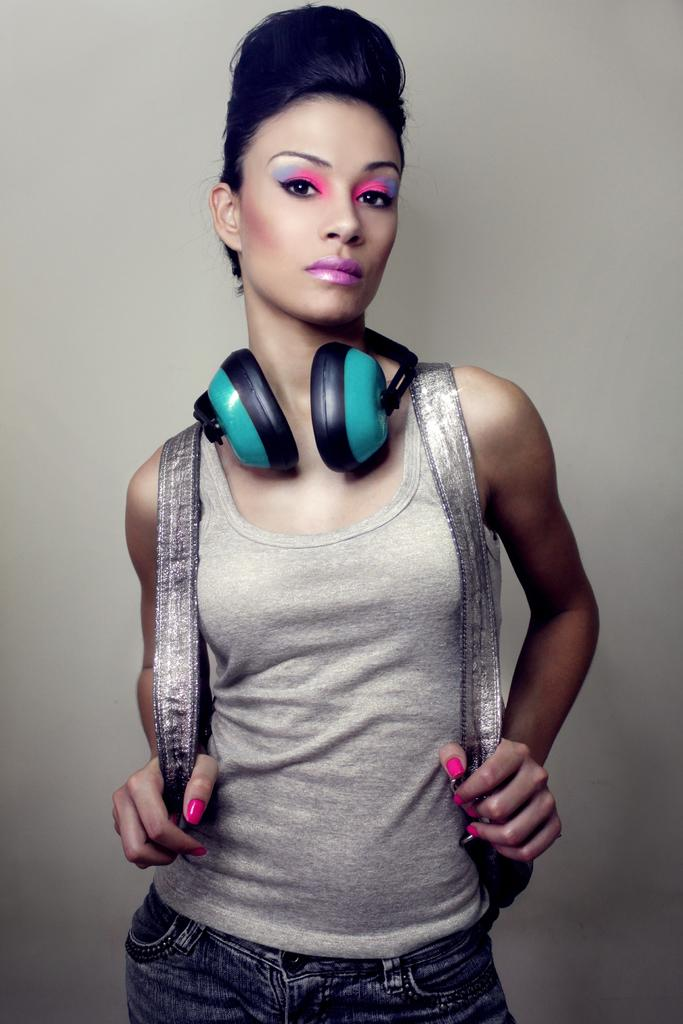Who is the main subject in the image? There is a woman in the image. What is the woman doing in the image? The woman is standing and appears to be posing for a photo. What is the woman wearing in the image? The woman is wearing a bag and has headphones around her neck. What type of popcorn is the woman holding in the image? There is no popcorn present in the image. Is the woman a servant in the image? There is no indication in the image that the woman is a servant. 